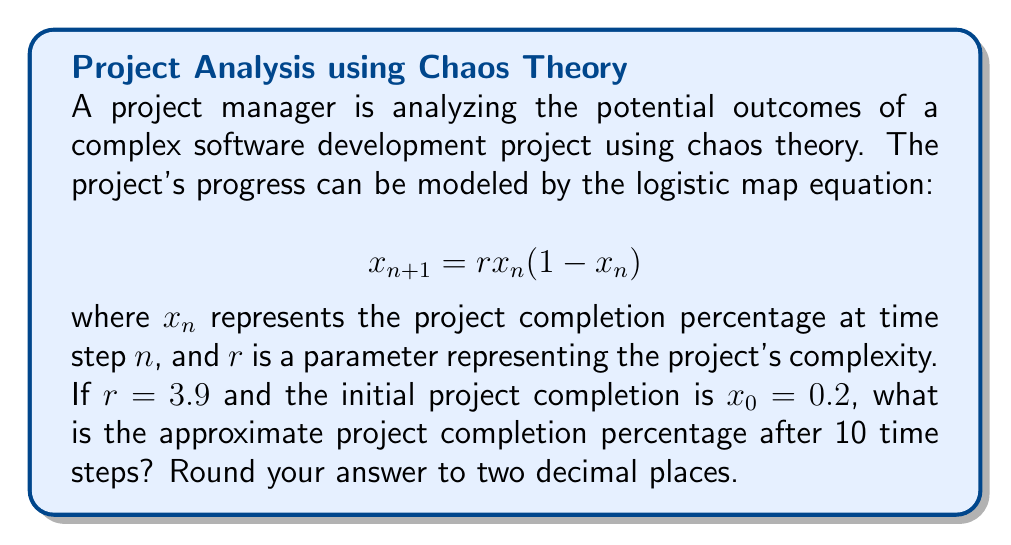Can you solve this math problem? To solve this problem, we need to iterate the logistic map equation for 10 time steps:

1) Start with $x_0 = 0.2$ and $r = 3.9$

2) Calculate $x_1$:
   $x_1 = 3.9 * 0.2 * (1 - 0.2) = 0.624$

3) Calculate $x_2$:
   $x_2 = 3.9 * 0.624 * (1 - 0.624) = 0.915456$

4) Continue this process for the remaining steps:
   $x_3 = 0.302357$
   $x_4 = 0.822700$
   $x_5 = 0.569722$
   $x_6 = 0.956333$
   $x_7 = 0.162910$
   $x_8 = 0.532245$
   $x_9 = 0.972785$
   $x_{10} = 0.103871$

5) The final value after 10 time steps is $x_{10} = 0.103871$

6) Rounding to two decimal places: 0.10

This demonstrates the chaotic behavior of the project's progress, as small changes in initial conditions can lead to significantly different outcomes over time.
Answer: 0.10 